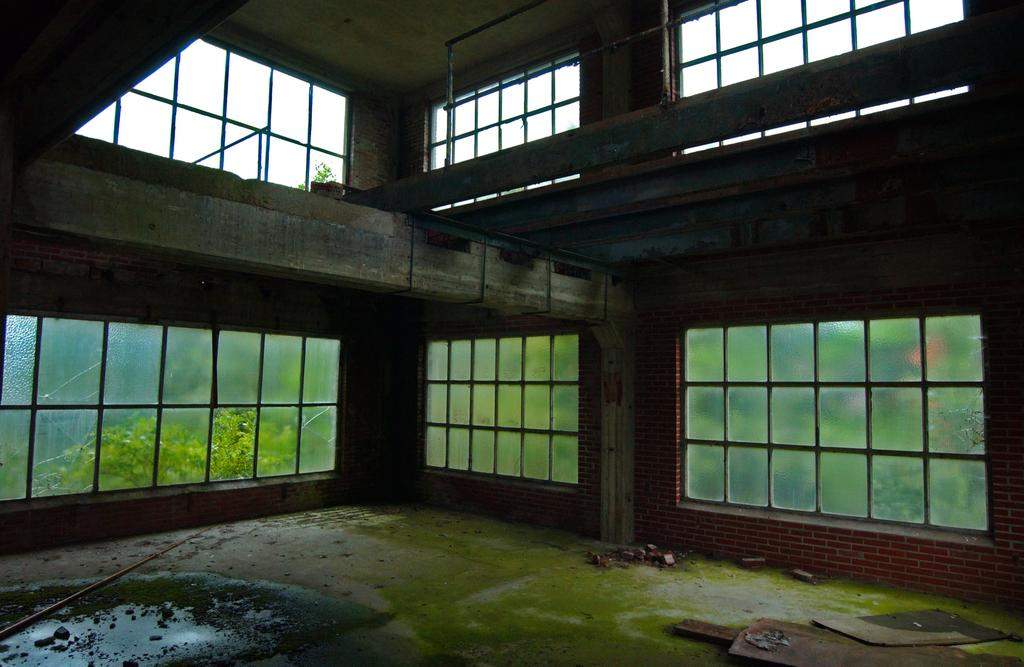Where was the image taken? The image was taken inside a building. What can be seen in the background of the image? There are metal rods, glasses, and trees in the background of the image. How many crayons are on the floor in the image? There are no crayons present in the image. What type of lizards can be seen crawling on the walls in the image? There are no lizards present in the image. 